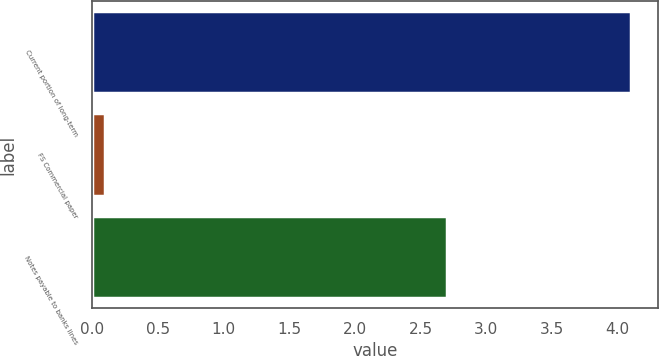<chart> <loc_0><loc_0><loc_500><loc_500><bar_chart><fcel>Current portion of long-term<fcel>FS Commercial paper<fcel>Notes payable to banks lines<nl><fcel>4.1<fcel>0.1<fcel>2.7<nl></chart> 